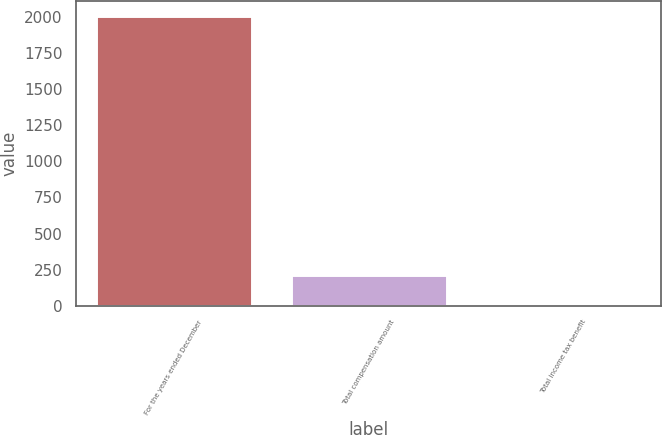Convert chart. <chart><loc_0><loc_0><loc_500><loc_500><bar_chart><fcel>For the years ended December<fcel>Total compensation amount<fcel>Total income tax benefit<nl><fcel>2008<fcel>212.59<fcel>13.1<nl></chart> 